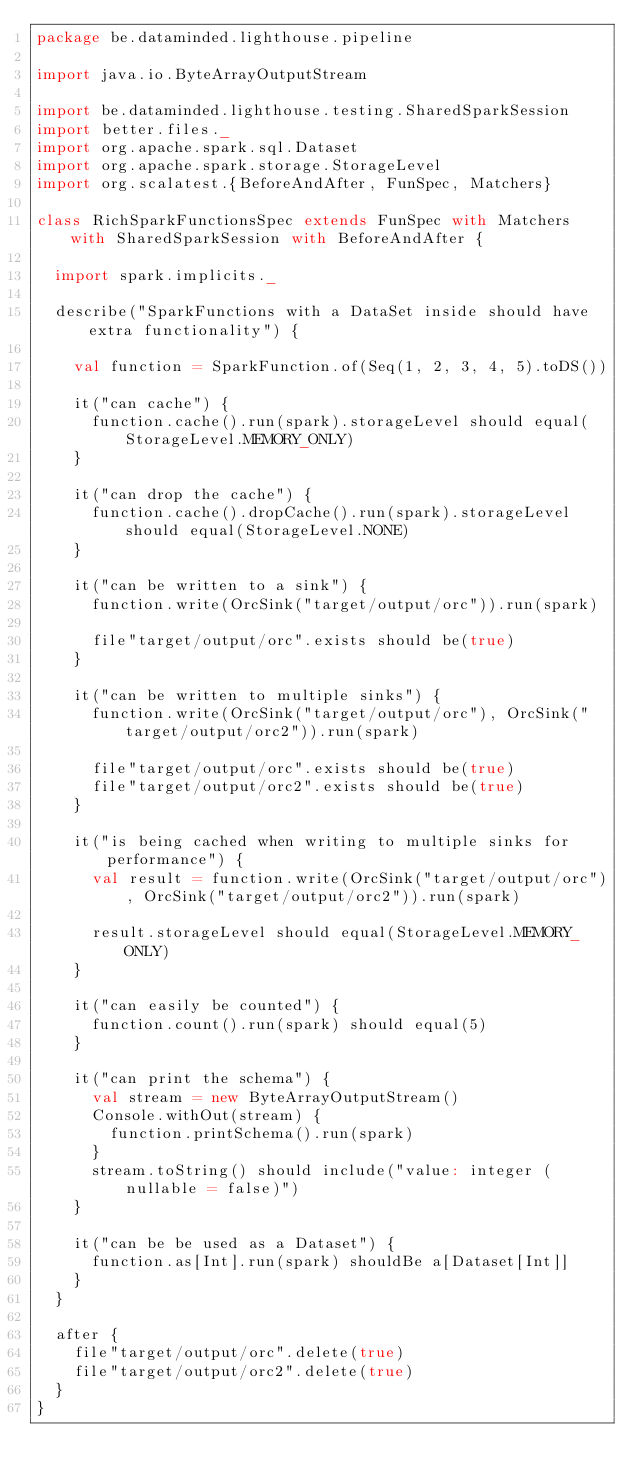<code> <loc_0><loc_0><loc_500><loc_500><_Scala_>package be.dataminded.lighthouse.pipeline

import java.io.ByteArrayOutputStream

import be.dataminded.lighthouse.testing.SharedSparkSession
import better.files._
import org.apache.spark.sql.Dataset
import org.apache.spark.storage.StorageLevel
import org.scalatest.{BeforeAndAfter, FunSpec, Matchers}

class RichSparkFunctionsSpec extends FunSpec with Matchers with SharedSparkSession with BeforeAndAfter {

  import spark.implicits._

  describe("SparkFunctions with a DataSet inside should have extra functionality") {

    val function = SparkFunction.of(Seq(1, 2, 3, 4, 5).toDS())

    it("can cache") {
      function.cache().run(spark).storageLevel should equal(StorageLevel.MEMORY_ONLY)
    }

    it("can drop the cache") {
      function.cache().dropCache().run(spark).storageLevel should equal(StorageLevel.NONE)
    }

    it("can be written to a sink") {
      function.write(OrcSink("target/output/orc")).run(spark)

      file"target/output/orc".exists should be(true)
    }

    it("can be written to multiple sinks") {
      function.write(OrcSink("target/output/orc"), OrcSink("target/output/orc2")).run(spark)

      file"target/output/orc".exists should be(true)
      file"target/output/orc2".exists should be(true)
    }

    it("is being cached when writing to multiple sinks for performance") {
      val result = function.write(OrcSink("target/output/orc"), OrcSink("target/output/orc2")).run(spark)

      result.storageLevel should equal(StorageLevel.MEMORY_ONLY)
    }

    it("can easily be counted") {
      function.count().run(spark) should equal(5)
    }

    it("can print the schema") {
      val stream = new ByteArrayOutputStream()
      Console.withOut(stream) {
        function.printSchema().run(spark)
      }
      stream.toString() should include("value: integer (nullable = false)")
    }

    it("can be be used as a Dataset") {
      function.as[Int].run(spark) shouldBe a[Dataset[Int]]
    }
  }

  after {
    file"target/output/orc".delete(true)
    file"target/output/orc2".delete(true)
  }
}
</code> 